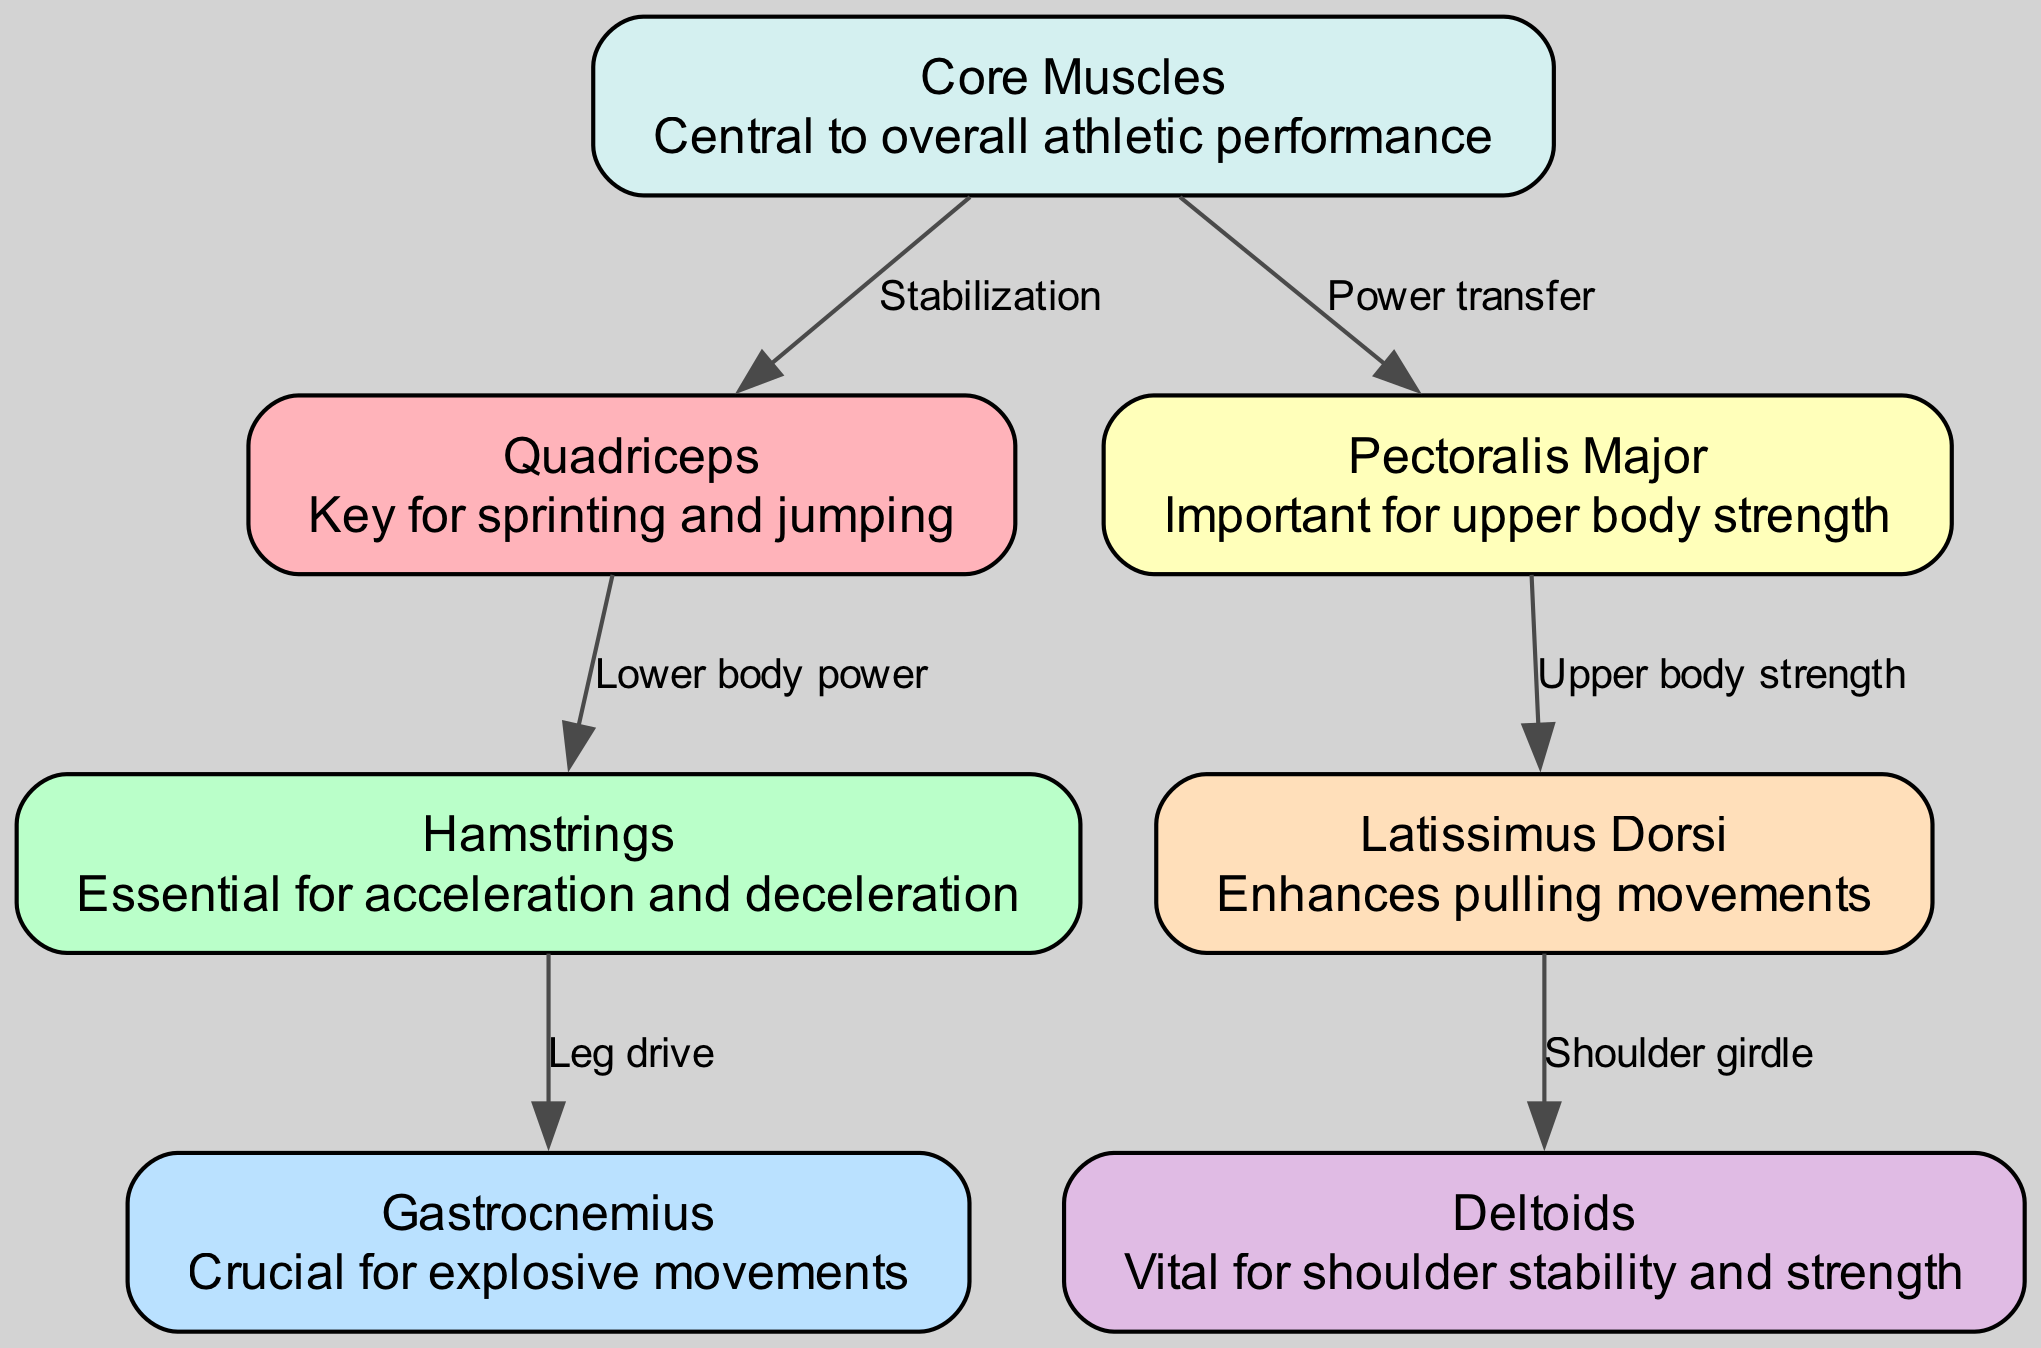What is the muscle group responsible for sprinting and jumping? The diagram shows "Quadriceps" as the node associated with the description "Key for sprinting and jumping." This indicates that the quadriceps are essential for these movements in athletic performance.
Answer: Quadriceps How many major muscle groups are highlighted in the diagram? By counting the nodes listed in the provided data, there are a total of seven major muscle groups represented in the diagram.
Answer: 7 Which muscle group is indicated as crucial for explosive movements? The "Gastrocnemius" is identified in the diagram as "Crucial for explosive movements," making it the answer to this question.
Answer: Gastrocnemius What label connects the Quadriceps to the Hamstrings? The edge connecting the Quadriceps node to the Hamstrings node is labeled "Lower body power," which indicates the relationship between these two muscle groups.
Answer: Lower body power Which two muscle groups are linked by the edge labeled "Power transfer"? In the diagram, the edge labeled "Power transfer" connects the Core Muscles to the Pectoralis Major, highlighting their relationship in athletic performance.
Answer: Core Muscles, Pectoralis Major Explain the relationship between Core Muscles and Quadriceps in terms of stabilizing forces. The diagram shows an edge connecting the Core Muscles to the Quadriceps labeled "Stabilization." This indicates that the Core Muscles play a role in stabilizing and supporting the action of the Quadriceps during athletic activities. Therefore, they are interdependent in terms of performance.
Answer: Stabilization How is shoulder stability and strength related to Deltoids? The Deltoids node in the diagram does not directly connect to other nodes. However, it is noted as "Vital for shoulder stability and strength," emphasizing its role in upper body stability, particularly during arm movements in sports.
Answer: Vital for shoulder stability and strength Which muscle group enhances pulling movements? The Latissimus Dorsi is highlighted in the diagram with the description "Enhances pulling movements," indicating its specific function in athletic activities.
Answer: Latissimus Dorsi What connects the Pectoralis Major to the Latissimus Dorsi? The connection between the Pectoralis Major and the Latissimus Dorsi in the diagram is represented as "Upper body strength," illustrating the relationship of these muscle groups in supporting upper body athletic functions.
Answer: Upper body strength 